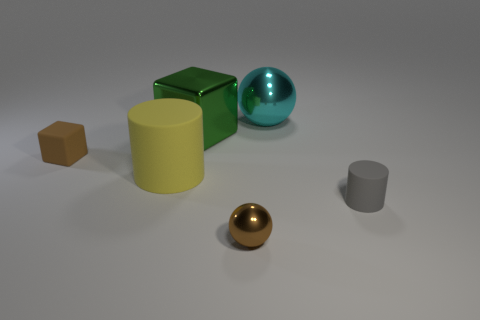The metallic object that is the same color as the tiny matte cube is what size?
Keep it short and to the point. Small. There is a rubber thing that is on the right side of the green block; is it the same size as the brown object that is on the left side of the green shiny thing?
Ensure brevity in your answer.  Yes. There is a tiny object that is both right of the green metal object and to the left of the tiny gray object; what material is it made of?
Your answer should be compact. Metal. Are there fewer metal spheres than small brown matte cubes?
Your response must be concise. No. There is a matte cylinder behind the small rubber object that is in front of the brown cube; what size is it?
Keep it short and to the point. Large. What is the shape of the small object left of the sphere that is on the left side of the metal ball that is on the right side of the small metallic sphere?
Offer a terse response. Cube. What is the color of the cube that is the same material as the large cylinder?
Keep it short and to the point. Brown. The thing that is on the left side of the large thing in front of the small brown thing behind the small brown shiny object is what color?
Your answer should be very brief. Brown. What number of cylinders are either big yellow rubber things or gray things?
Provide a succinct answer. 2. There is a sphere that is the same color as the small rubber cube; what material is it?
Your response must be concise. Metal. 